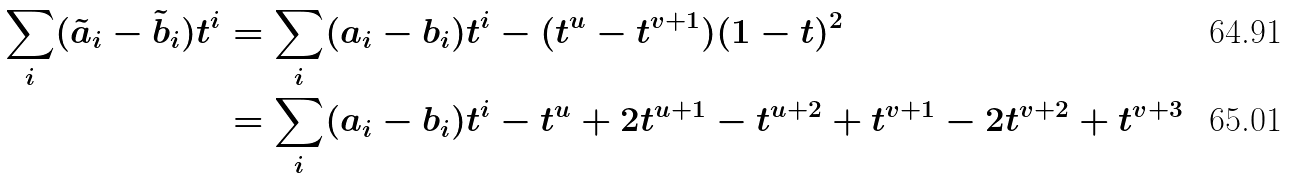<formula> <loc_0><loc_0><loc_500><loc_500>\sum _ { i } ( \tilde { a } _ { i } - \tilde { b } _ { i } ) t ^ { i } & = \sum _ { i } ( a _ { i } - b _ { i } ) t ^ { i } - ( t ^ { u } - t ^ { v + 1 } ) ( 1 - t ) ^ { 2 } \\ & = \sum _ { i } ( a _ { i } - b _ { i } ) t ^ { i } - t ^ { u } + 2 t ^ { u + 1 } - t ^ { u + 2 } + t ^ { v + 1 } - 2 t ^ { v + 2 } + t ^ { v + 3 }</formula> 